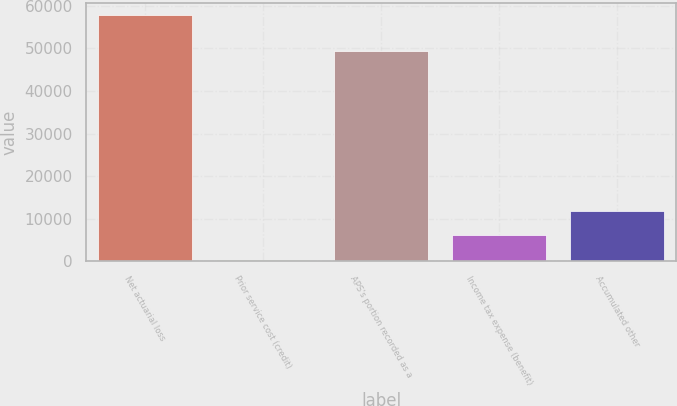Convert chart to OTSL. <chart><loc_0><loc_0><loc_500><loc_500><bar_chart><fcel>Net actuarial loss<fcel>Prior service cost (credit)<fcel>APS's portion recorded as a<fcel>Income tax expense (benefit)<fcel>Accumulated other<nl><fcel>57816<fcel>296<fcel>49298<fcel>6048<fcel>11800<nl></chart> 